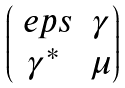<formula> <loc_0><loc_0><loc_500><loc_500>\begin{pmatrix} \ e p s & \gamma \\ \gamma ^ { * } & \mu \end{pmatrix}</formula> 